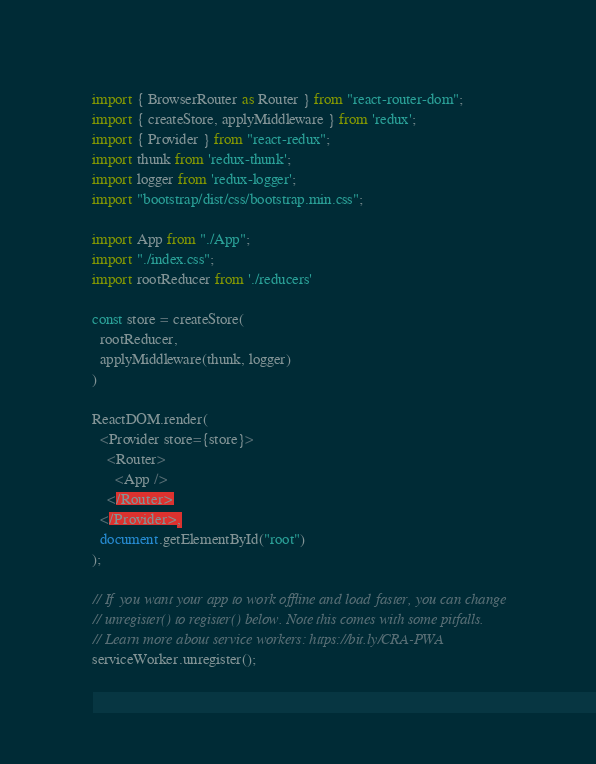<code> <loc_0><loc_0><loc_500><loc_500><_JavaScript_>import { BrowserRouter as Router } from "react-router-dom";
import { createStore, applyMiddleware } from 'redux';
import { Provider } from "react-redux";
import thunk from 'redux-thunk';
import logger from 'redux-logger';
import "bootstrap/dist/css/bootstrap.min.css";

import App from "./App";
import "./index.css";
import rootReducer from './reducers'

const store = createStore(
  rootReducer,
  applyMiddleware(thunk, logger)
)

ReactDOM.render(
  <Provider store={store}>
    <Router>
      <App />
    </Router>
  </Provider>,
  document.getElementById("root")
);

// If you want your app to work offline and load faster, you can change
// unregister() to register() below. Note this comes with some pitfalls.
// Learn more about service workers: https://bit.ly/CRA-PWA
serviceWorker.unregister();
</code> 